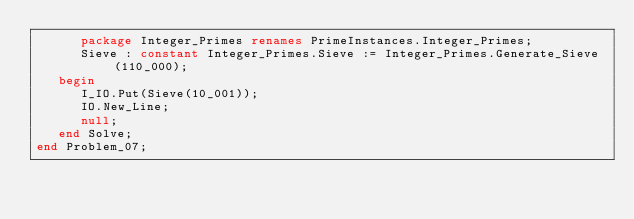Convert code to text. <code><loc_0><loc_0><loc_500><loc_500><_Ada_>      package Integer_Primes renames PrimeInstances.Integer_Primes;
      Sieve : constant Integer_Primes.Sieve := Integer_Primes.Generate_Sieve(110_000);
   begin
      I_IO.Put(Sieve(10_001));
      IO.New_Line;
      null;
   end Solve;
end Problem_07;
</code> 